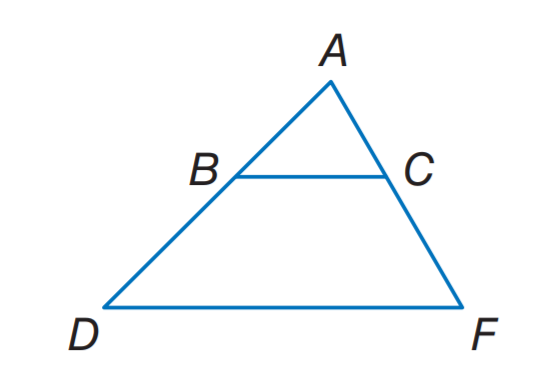Answer the mathemtical geometry problem and directly provide the correct option letter.
Question: B C \parallel D F. A B = x + 5, B D = 12, A C = 3 x + 1, and C F = 15. Find x.
Choices: A: 3 B: 4 C: 5 D: 6 A 